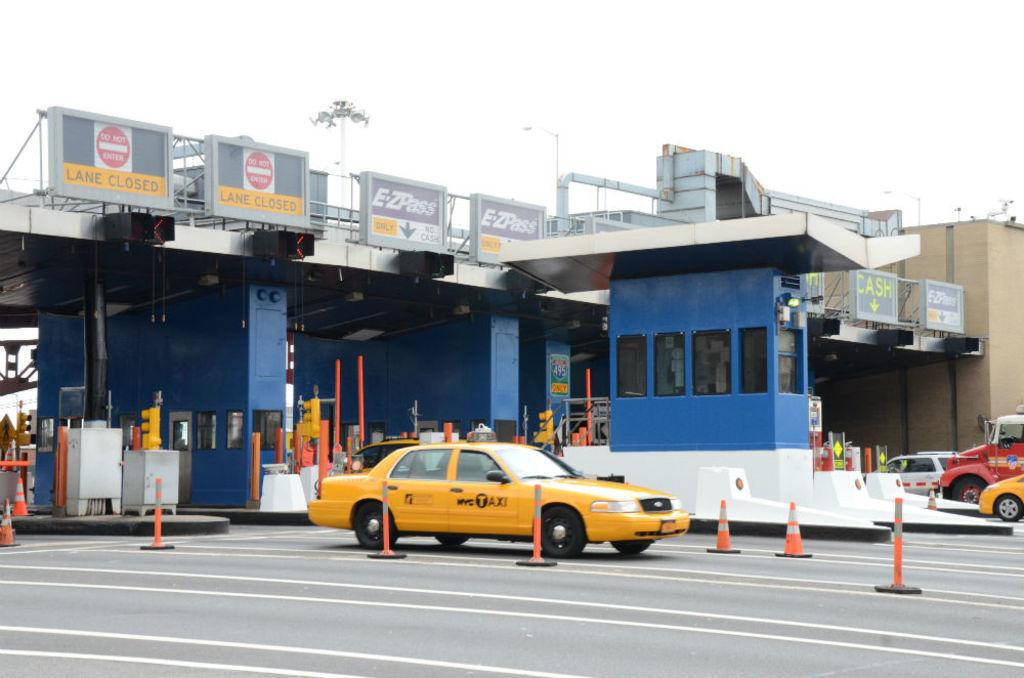<image>
Describe the image concisely. A yellow NYC Taxi passes through a toll gate, which has Do Not Enter signs above it. 